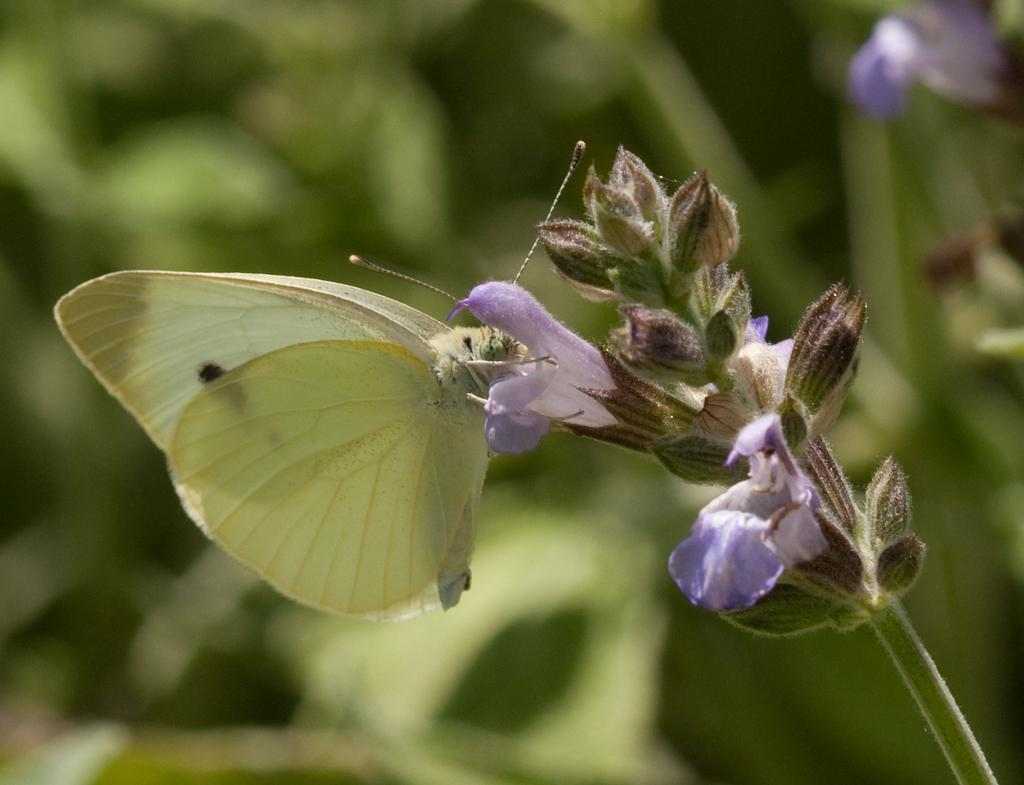What is the main subject of the image? There is a butterfly in the image. Where is the butterfly located? The butterfly is on a flower. Can you describe the flower and its location? The flower is on the stem of a plant. What type of writing can be seen on the brick in the image? There is no brick present in the image, and therefore no writing can be seen on it. 